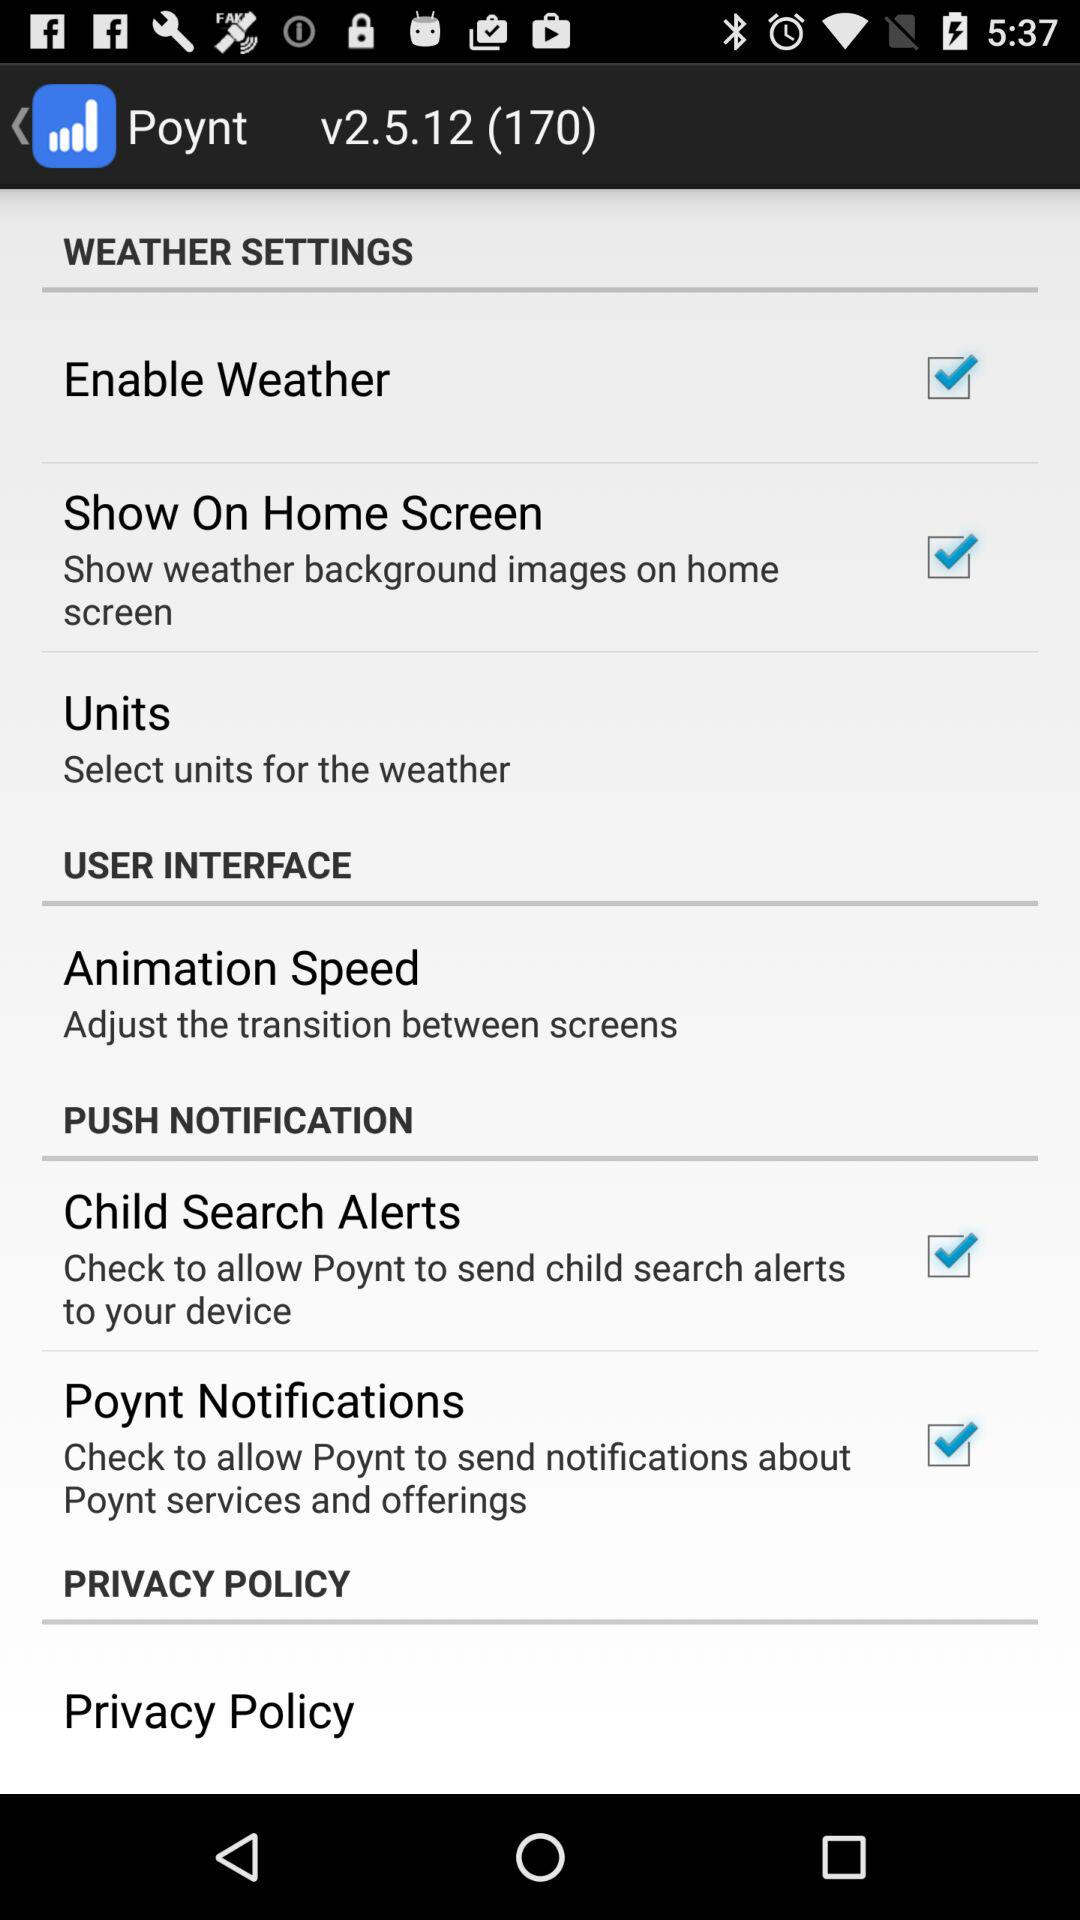How many checkboxes are in the push notifications section?
Answer the question using a single word or phrase. 2 